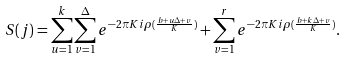Convert formula to latex. <formula><loc_0><loc_0><loc_500><loc_500>S ( j ) = \sum _ { u = 1 } ^ { k } \sum _ { v = 1 } ^ { \Delta } e ^ { - 2 \pi K i \rho ( \frac { b + u \Delta + v } K ) } + \sum _ { v = 1 } ^ { r } e ^ { - 2 \pi K i \rho ( \frac { b + k \Delta + v } K ) } .</formula> 